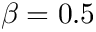<formula> <loc_0><loc_0><loc_500><loc_500>\beta = 0 . 5</formula> 